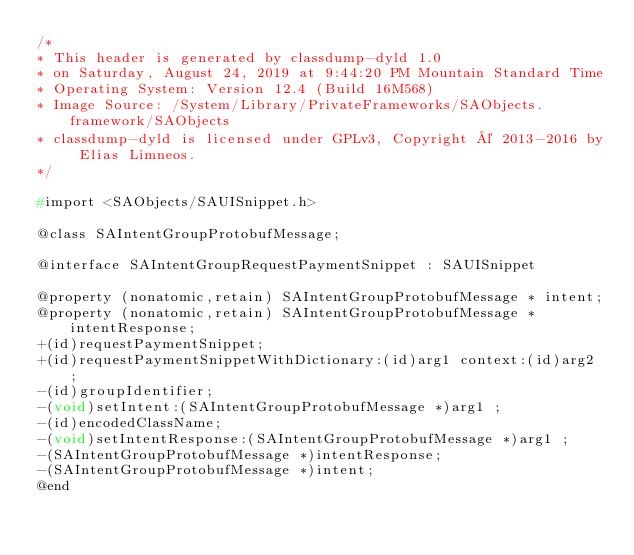<code> <loc_0><loc_0><loc_500><loc_500><_C_>/*
* This header is generated by classdump-dyld 1.0
* on Saturday, August 24, 2019 at 9:44:20 PM Mountain Standard Time
* Operating System: Version 12.4 (Build 16M568)
* Image Source: /System/Library/PrivateFrameworks/SAObjects.framework/SAObjects
* classdump-dyld is licensed under GPLv3, Copyright © 2013-2016 by Elias Limneos.
*/

#import <SAObjects/SAUISnippet.h>

@class SAIntentGroupProtobufMessage;

@interface SAIntentGroupRequestPaymentSnippet : SAUISnippet

@property (nonatomic,retain) SAIntentGroupProtobufMessage * intent; 
@property (nonatomic,retain) SAIntentGroupProtobufMessage * intentResponse; 
+(id)requestPaymentSnippet;
+(id)requestPaymentSnippetWithDictionary:(id)arg1 context:(id)arg2 ;
-(id)groupIdentifier;
-(void)setIntent:(SAIntentGroupProtobufMessage *)arg1 ;
-(id)encodedClassName;
-(void)setIntentResponse:(SAIntentGroupProtobufMessage *)arg1 ;
-(SAIntentGroupProtobufMessage *)intentResponse;
-(SAIntentGroupProtobufMessage *)intent;
@end

</code> 